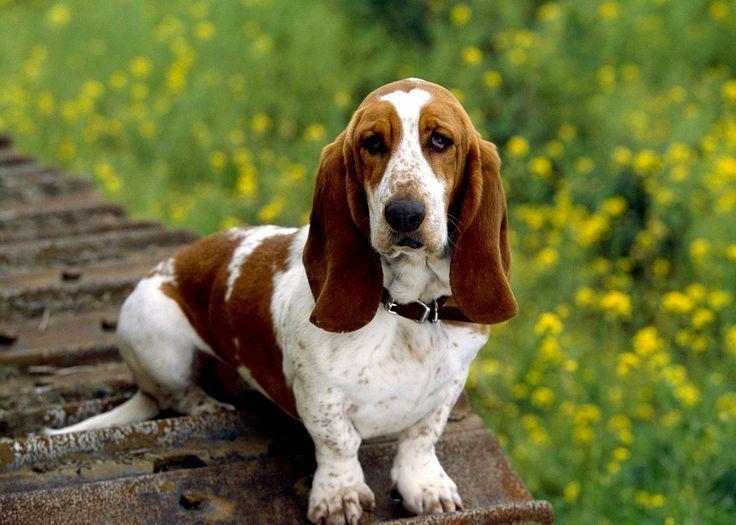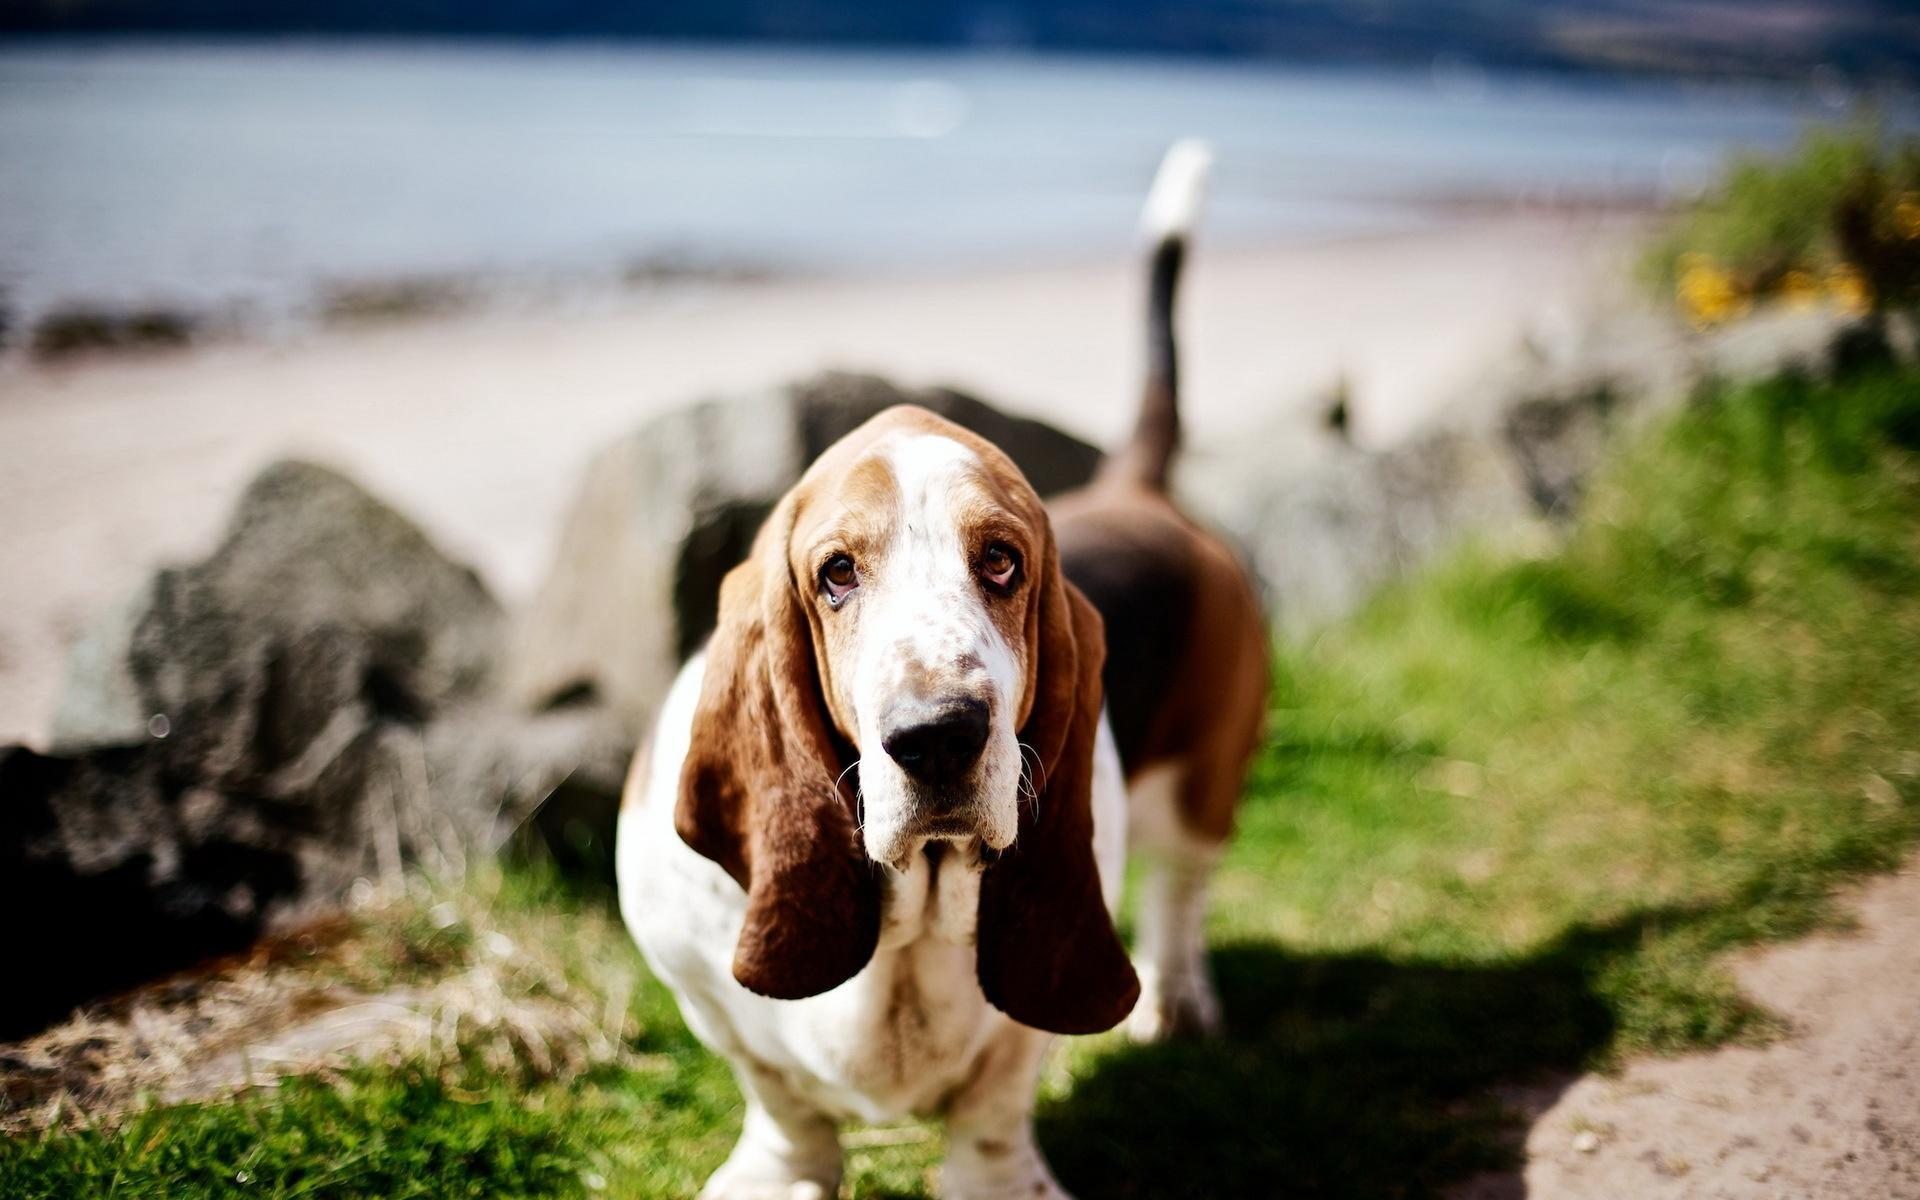The first image is the image on the left, the second image is the image on the right. Assess this claim about the two images: "One of the image shows a single dog on a leash and the other shows a group of at least three dogs.". Correct or not? Answer yes or no. No. The first image is the image on the left, the second image is the image on the right. Analyze the images presented: Is the assertion "In total, we have more than two dogs here." valid? Answer yes or no. No. 